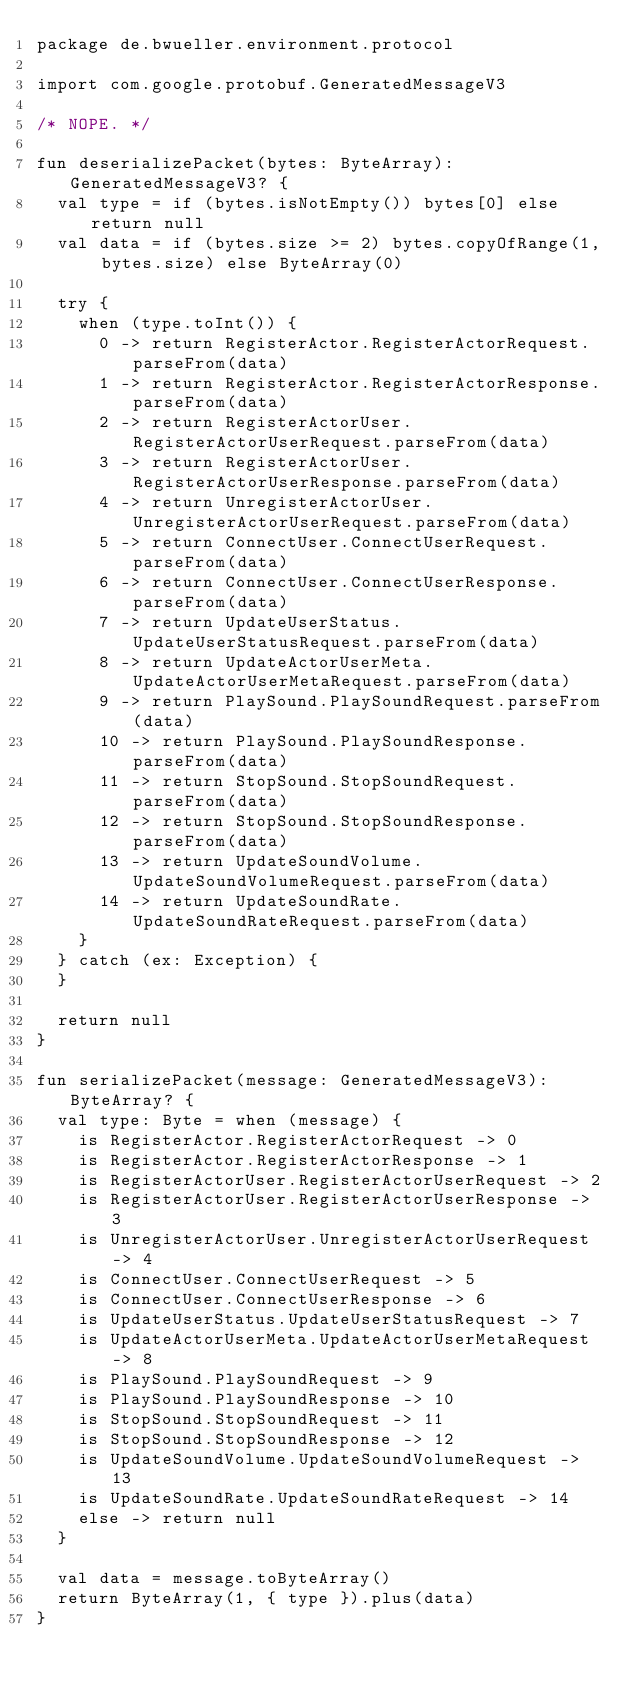<code> <loc_0><loc_0><loc_500><loc_500><_Kotlin_>package de.bwueller.environment.protocol

import com.google.protobuf.GeneratedMessageV3

/* NOPE. */

fun deserializePacket(bytes: ByteArray): GeneratedMessageV3? {
  val type = if (bytes.isNotEmpty()) bytes[0] else return null
  val data = if (bytes.size >= 2) bytes.copyOfRange(1, bytes.size) else ByteArray(0)

  try {
    when (type.toInt()) {
      0 -> return RegisterActor.RegisterActorRequest.parseFrom(data)
      1 -> return RegisterActor.RegisterActorResponse.parseFrom(data)
      2 -> return RegisterActorUser.RegisterActorUserRequest.parseFrom(data)
      3 -> return RegisterActorUser.RegisterActorUserResponse.parseFrom(data)
      4 -> return UnregisterActorUser.UnregisterActorUserRequest.parseFrom(data)
      5 -> return ConnectUser.ConnectUserRequest.parseFrom(data)
      6 -> return ConnectUser.ConnectUserResponse.parseFrom(data)
      7 -> return UpdateUserStatus.UpdateUserStatusRequest.parseFrom(data)
      8 -> return UpdateActorUserMeta.UpdateActorUserMetaRequest.parseFrom(data)
      9 -> return PlaySound.PlaySoundRequest.parseFrom(data)
      10 -> return PlaySound.PlaySoundResponse.parseFrom(data)
      11 -> return StopSound.StopSoundRequest.parseFrom(data)
      12 -> return StopSound.StopSoundResponse.parseFrom(data)
      13 -> return UpdateSoundVolume.UpdateSoundVolumeRequest.parseFrom(data)
      14 -> return UpdateSoundRate.UpdateSoundRateRequest.parseFrom(data)
    }
  } catch (ex: Exception) {
  }

  return null
}

fun serializePacket(message: GeneratedMessageV3): ByteArray? {
  val type: Byte = when (message) {
    is RegisterActor.RegisterActorRequest -> 0
    is RegisterActor.RegisterActorResponse -> 1
    is RegisterActorUser.RegisterActorUserRequest -> 2
    is RegisterActorUser.RegisterActorUserResponse -> 3
    is UnregisterActorUser.UnregisterActorUserRequest -> 4
    is ConnectUser.ConnectUserRequest -> 5
    is ConnectUser.ConnectUserResponse -> 6
    is UpdateUserStatus.UpdateUserStatusRequest -> 7
    is UpdateActorUserMeta.UpdateActorUserMetaRequest -> 8
    is PlaySound.PlaySoundRequest -> 9
    is PlaySound.PlaySoundResponse -> 10
    is StopSound.StopSoundRequest -> 11
    is StopSound.StopSoundResponse -> 12
    is UpdateSoundVolume.UpdateSoundVolumeRequest -> 13
    is UpdateSoundRate.UpdateSoundRateRequest -> 14
    else -> return null
  }

  val data = message.toByteArray()
  return ByteArray(1, { type }).plus(data)
}
</code> 